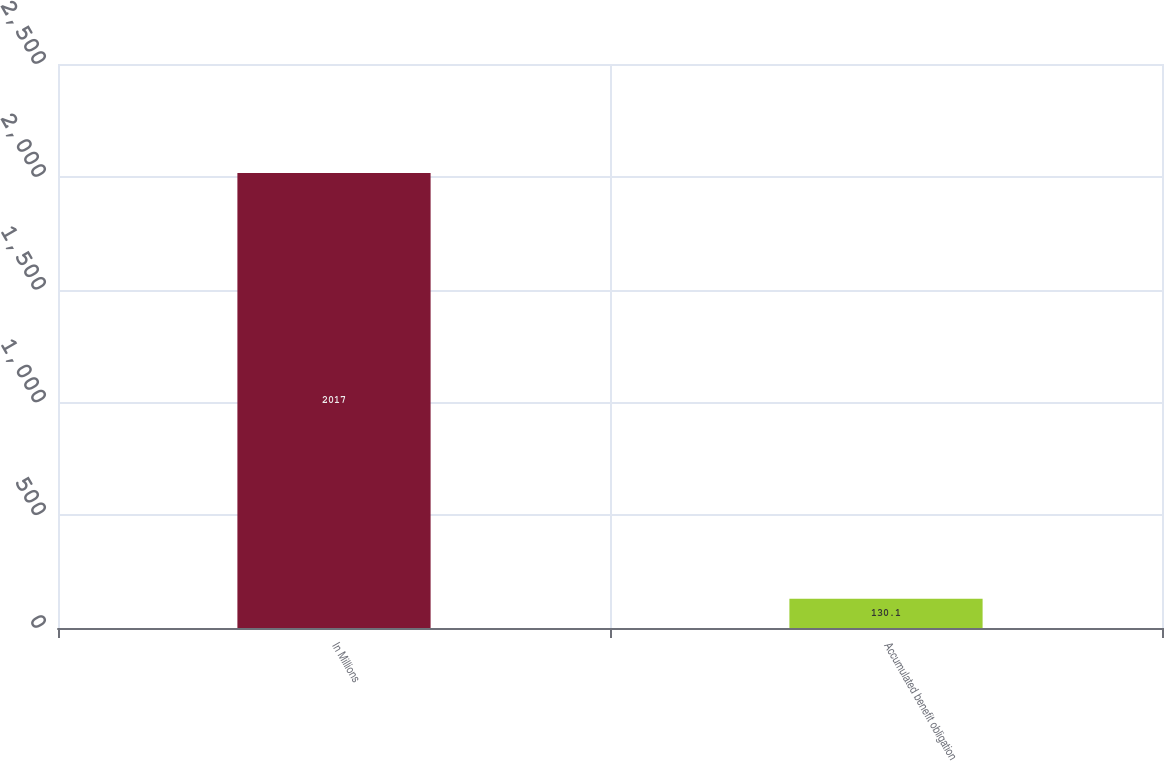Convert chart to OTSL. <chart><loc_0><loc_0><loc_500><loc_500><bar_chart><fcel>In Millions<fcel>Accumulated benefit obligation<nl><fcel>2017<fcel>130.1<nl></chart> 